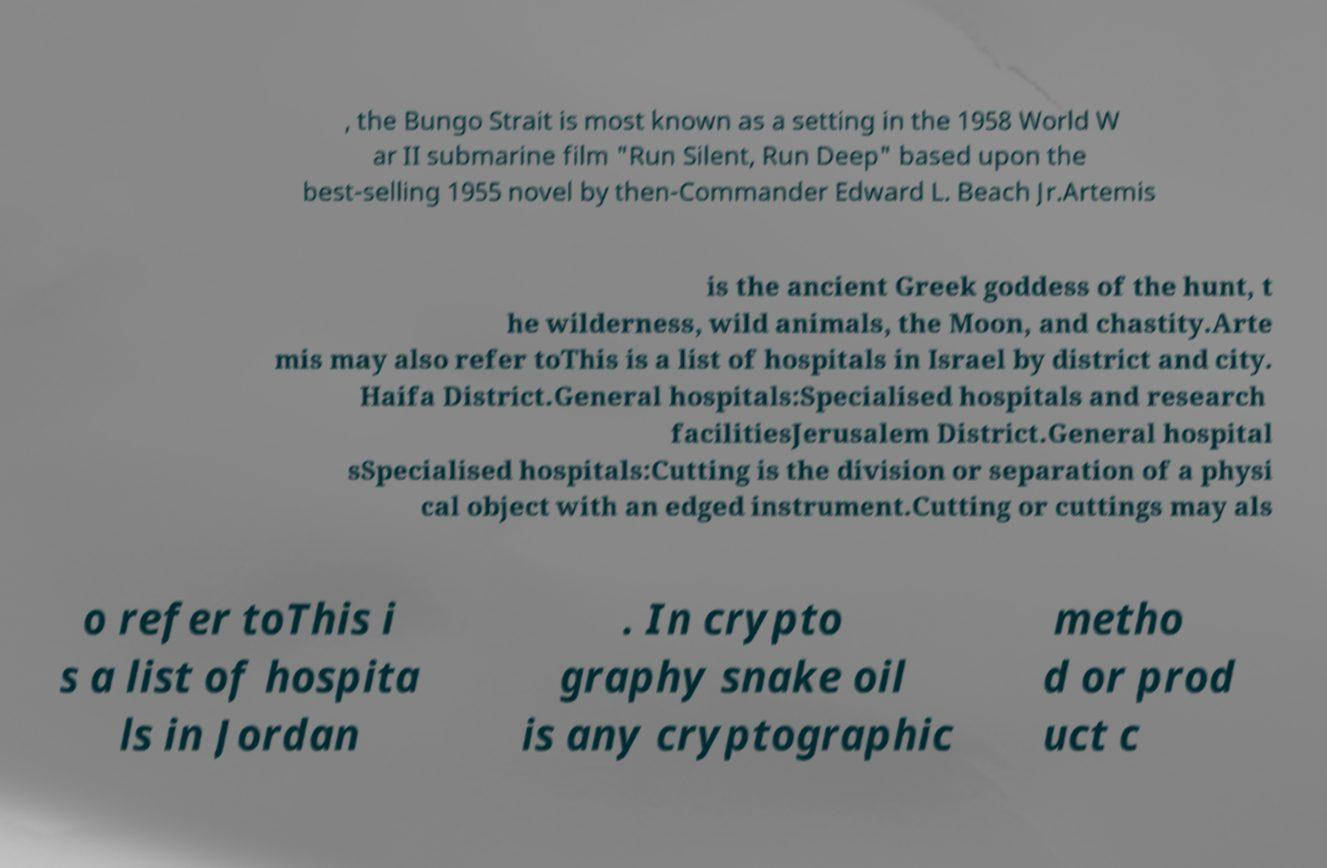Please identify and transcribe the text found in this image. , the Bungo Strait is most known as a setting in the 1958 World W ar II submarine film "Run Silent, Run Deep" based upon the best-selling 1955 novel by then-Commander Edward L. Beach Jr.Artemis is the ancient Greek goddess of the hunt, t he wilderness, wild animals, the Moon, and chastity.Arte mis may also refer toThis is a list of hospitals in Israel by district and city. Haifa District.General hospitals:Specialised hospitals and research facilitiesJerusalem District.General hospital sSpecialised hospitals:Cutting is the division or separation of a physi cal object with an edged instrument.Cutting or cuttings may als o refer toThis i s a list of hospita ls in Jordan . In crypto graphy snake oil is any cryptographic metho d or prod uct c 